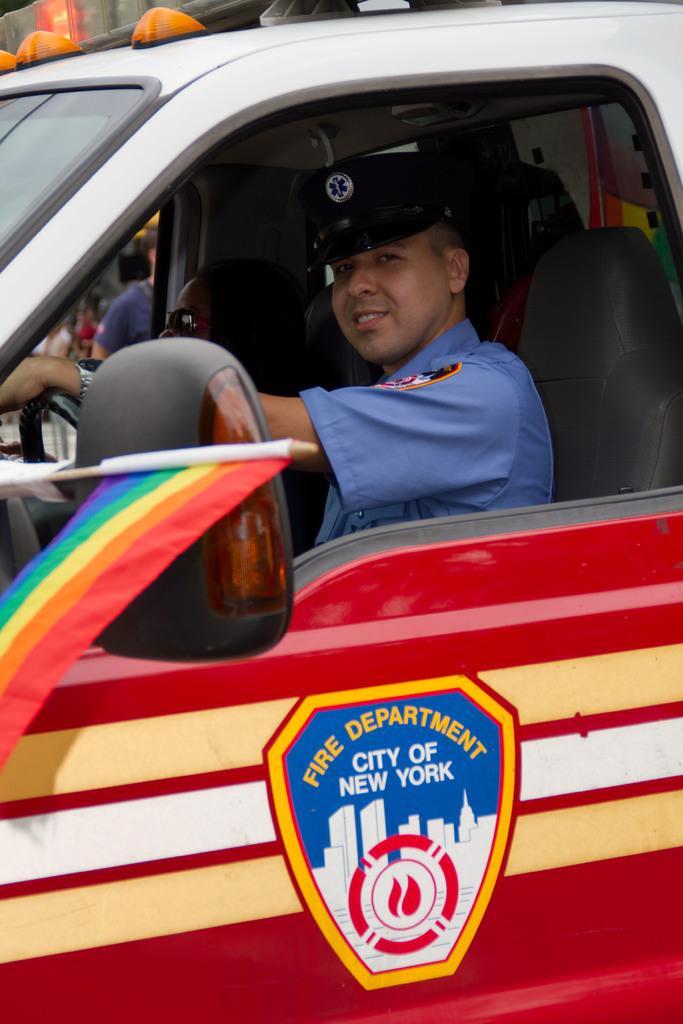How would you summarize this image in a sentence or two? This picture shows a man driving car and we see "fire department city of New York" written on it 